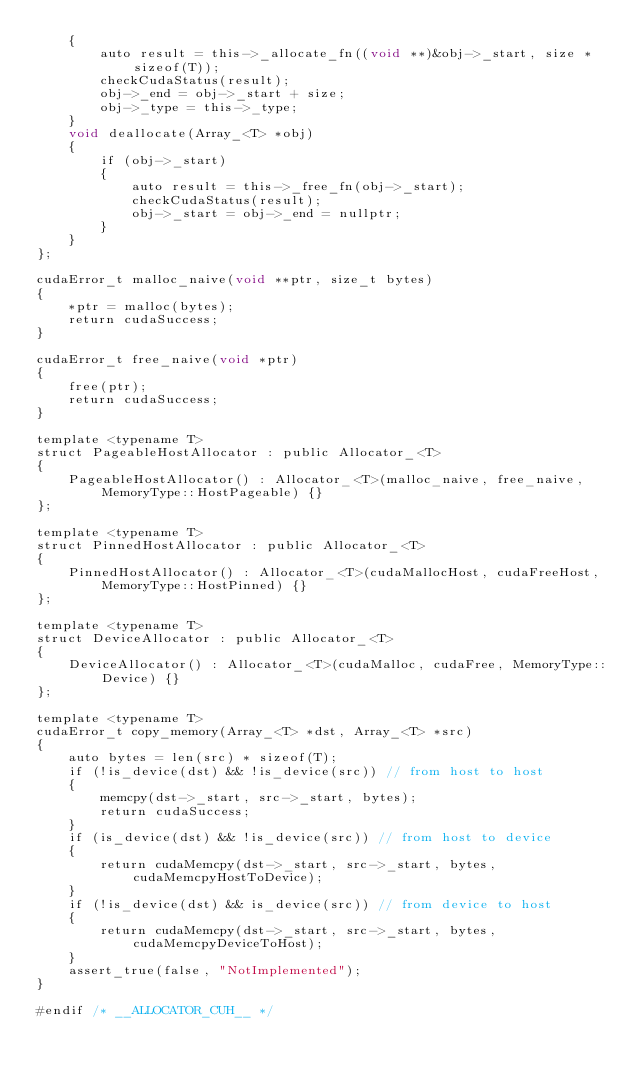Convert code to text. <code><loc_0><loc_0><loc_500><loc_500><_Cuda_>    {
        auto result = this->_allocate_fn((void **)&obj->_start, size * sizeof(T));
        checkCudaStatus(result);
        obj->_end = obj->_start + size;
        obj->_type = this->_type;
    }
    void deallocate(Array_<T> *obj)
    {
        if (obj->_start)
        {
            auto result = this->_free_fn(obj->_start);
            checkCudaStatus(result);
            obj->_start = obj->_end = nullptr;
        }
    }
};

cudaError_t malloc_naive(void **ptr, size_t bytes)
{
    *ptr = malloc(bytes);
    return cudaSuccess;
}

cudaError_t free_naive(void *ptr)
{
    free(ptr);
    return cudaSuccess;
}

template <typename T>
struct PageableHostAllocator : public Allocator_<T>
{
    PageableHostAllocator() : Allocator_<T>(malloc_naive, free_naive, MemoryType::HostPageable) {}
};

template <typename T>
struct PinnedHostAllocator : public Allocator_<T>
{
    PinnedHostAllocator() : Allocator_<T>(cudaMallocHost, cudaFreeHost, MemoryType::HostPinned) {}
};

template <typename T>
struct DeviceAllocator : public Allocator_<T>
{
    DeviceAllocator() : Allocator_<T>(cudaMalloc, cudaFree, MemoryType::Device) {}
};

template <typename T>
cudaError_t copy_memory(Array_<T> *dst, Array_<T> *src)
{
    auto bytes = len(src) * sizeof(T);
    if (!is_device(dst) && !is_device(src)) // from host to host
    {
        memcpy(dst->_start, src->_start, bytes);
        return cudaSuccess;
    }
    if (is_device(dst) && !is_device(src)) // from host to device
    {
        return cudaMemcpy(dst->_start, src->_start, bytes, cudaMemcpyHostToDevice);
    }
    if (!is_device(dst) && is_device(src)) // from device to host
    {
        return cudaMemcpy(dst->_start, src->_start, bytes, cudaMemcpyDeviceToHost);
    }
    assert_true(false, "NotImplemented");
}

#endif /* __ALLOCATOR_CUH__ */
</code> 